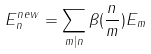<formula> <loc_0><loc_0><loc_500><loc_500>E ^ { n e w } _ { n } = \sum _ { m | n } \beta ( \frac { n } { m } ) E _ { m }</formula> 